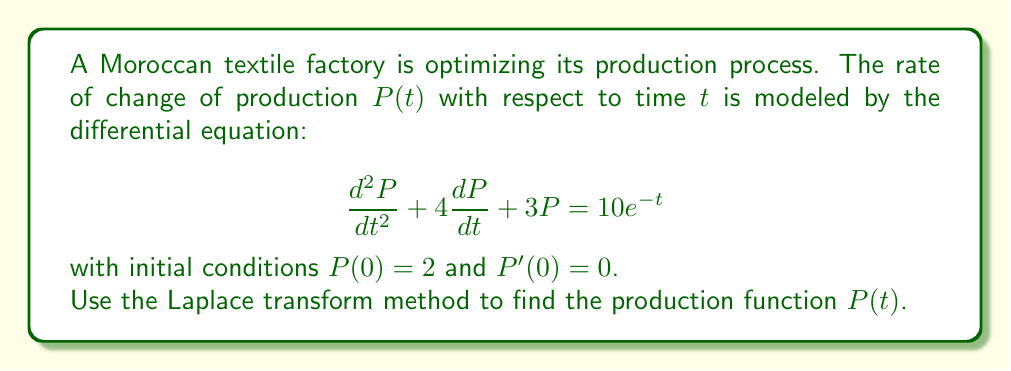Can you answer this question? Let's solve this step-by-step using the Laplace transform method:

1) Take the Laplace transform of both sides of the equation:
   $$\mathcal{L}\left\{\frac{d^2P}{dt^2} + 4\frac{dP}{dt} + 3P\right\} = \mathcal{L}\{10e^{-t}\}$$

2) Using Laplace transform properties:
   $$s^2P(s) - sP(0) - P'(0) + 4[sP(s) - P(0)] + 3P(s) = \frac{10}{s+1}$$

3) Substitute the initial conditions $P(0) = 2$ and $P'(0) = 0$:
   $$s^2P(s) - 2s + 4sP(s) - 8 + 3P(s) = \frac{10}{s+1}$$

4) Combine like terms:
   $$(s^2 + 4s + 3)P(s) = \frac{10}{s+1} + 2s + 8$$

5) Solve for $P(s)$:
   $$P(s) = \frac{10}{(s+1)(s^2 + 4s + 3)} + \frac{2s + 8}{s^2 + 4s + 3}$$

6) Decompose the right side into partial fractions:
   $$P(s) = \frac{A}{s+1} + \frac{B}{s+1} + \frac{C}{s+3}$$

   Where $A$, $B$, and $C$ are constants to be determined.

7) Solve for $A$, $B$, and $C$:
   $$A = 2, B = -2, C = 2$$

8) Rewrite $P(s)$:
   $$P(s) = \frac{2}{s+1} + \frac{-2}{s+1} + \frac{2}{s+3}$$

9) Take the inverse Laplace transform:
   $$P(t) = 2e^{-t} - 2te^{-t} + 2e^{-3t}$$

This is the production function $P(t)$.
Answer: $$P(t) = 2e^{-t} - 2te^{-t} + 2e^{-3t}$$ 